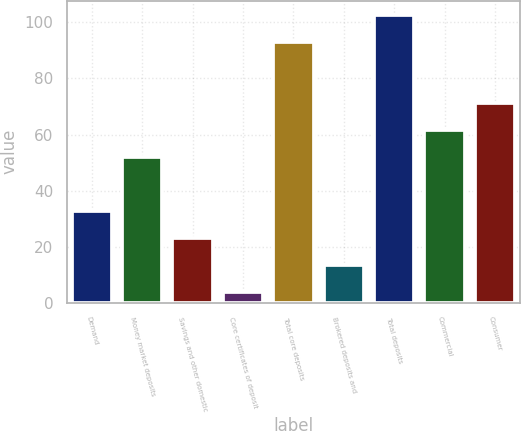<chart> <loc_0><loc_0><loc_500><loc_500><bar_chart><fcel>Demand<fcel>Money market deposits<fcel>Savings and other domestic<fcel>Core certificates of deposit<fcel>Total core deposits<fcel>Brokered deposits and<fcel>Total deposits<fcel>Commercial<fcel>Consumer<nl><fcel>32.8<fcel>52<fcel>23.2<fcel>4<fcel>93<fcel>13.6<fcel>102.6<fcel>61.6<fcel>71.2<nl></chart> 